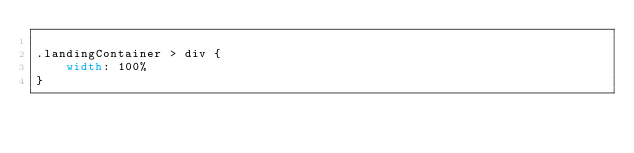<code> <loc_0><loc_0><loc_500><loc_500><_CSS_>
.landingContainer > div {
    width: 100%
}</code> 